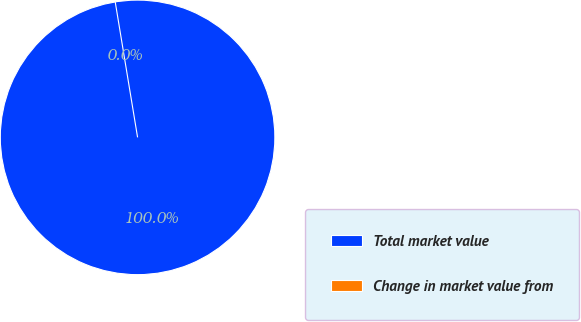Convert chart to OTSL. <chart><loc_0><loc_0><loc_500><loc_500><pie_chart><fcel>Total market value<fcel>Change in market value from<nl><fcel>100.0%<fcel>0.0%<nl></chart> 